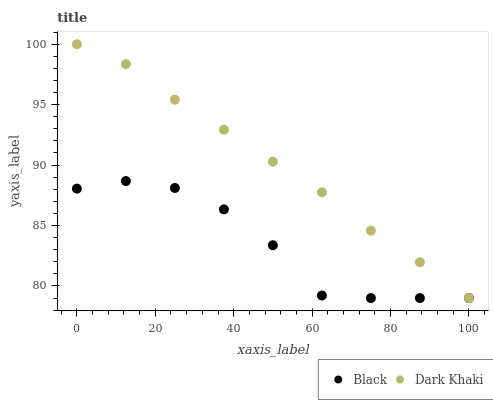Does Black have the minimum area under the curve?
Answer yes or no. Yes. Does Dark Khaki have the maximum area under the curve?
Answer yes or no. Yes. Does Black have the maximum area under the curve?
Answer yes or no. No. Is Dark Khaki the smoothest?
Answer yes or no. Yes. Is Black the roughest?
Answer yes or no. Yes. Is Black the smoothest?
Answer yes or no. No. Does Dark Khaki have the lowest value?
Answer yes or no. Yes. Does Dark Khaki have the highest value?
Answer yes or no. Yes. Does Black have the highest value?
Answer yes or no. No. Does Dark Khaki intersect Black?
Answer yes or no. Yes. Is Dark Khaki less than Black?
Answer yes or no. No. Is Dark Khaki greater than Black?
Answer yes or no. No. 